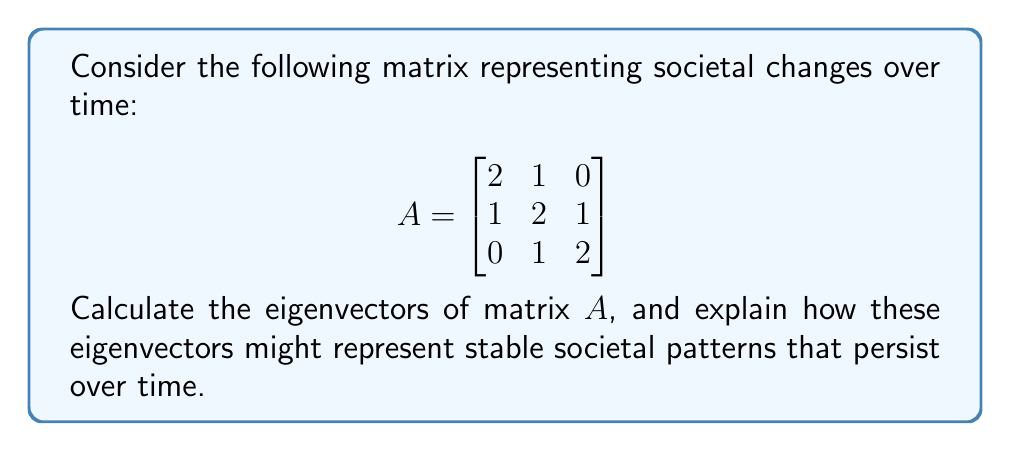Give your solution to this math problem. To find the eigenvectors of matrix $A$, we follow these steps:

1) First, we calculate the characteristic polynomial:
   $det(A - \lambda I) = \begin{vmatrix}
   2-\lambda & 1 & 0 \\
   1 & 2-\lambda & 1 \\
   0 & 1 & 2-\lambda
   \end{vmatrix} = 0$

2) Expanding this determinant:
   $(2-\lambda)^3 + 2 - 3(2-\lambda) = 0$
   $(2-\lambda)^3 - 3(2-\lambda) + 2 = 0$
   $\lambda^3 - 6\lambda^2 + 11\lambda - 6 = 0$

3) Factoring this polynomial:
   $(\lambda - 1)(\lambda - 2)(\lambda - 3) = 0$

4) So, the eigenvalues are $\lambda_1 = 1$, $\lambda_2 = 2$, and $\lambda_3 = 3$.

5) For each eigenvalue, we solve $(A - \lambda I)v = 0$ to find the corresponding eigenvector:

   For $\lambda_1 = 1$:
   $\begin{bmatrix}
   1 & 1 & 0 \\
   1 & 1 & 1 \\
   0 & 1 & 1
   \end{bmatrix} \begin{bmatrix} x \\ y \\ z \end{bmatrix} = \begin{bmatrix} 0 \\ 0 \\ 0 \end{bmatrix}$

   Solving this system, we get $v_1 = \begin{bmatrix} 1 \\ -1 \\ 1 \end{bmatrix}$

   For $\lambda_2 = 2$:
   $\begin{bmatrix}
   0 & 1 & 0 \\
   1 & 0 & 1 \\
   0 & 1 & 0
   \end{bmatrix} \begin{bmatrix} x \\ y \\ z \end{bmatrix} = \begin{bmatrix} 0 \\ 0 \\ 0 \end{bmatrix}$

   Solving this system, we get $v_2 = \begin{bmatrix} 1 \\ 0 \\ -1 \end{bmatrix}$

   For $\lambda_3 = 3$:
   $\begin{bmatrix}
   -1 & 1 & 0 \\
   1 & -1 & 1 \\
   0 & 1 & -1
   \end{bmatrix} \begin{bmatrix} x \\ y \\ z \end{bmatrix} = \begin{bmatrix} 0 \\ 0 \\ 0 \end{bmatrix}$

   Solving this system, we get $v_3 = \begin{bmatrix} 1 \\ 1 \\ 1 \end{bmatrix}$

These eigenvectors represent stable societal patterns that persist over time. The first eigenvector $v_1$ might represent a cyclical pattern, the second $v_2$ a polarizing trend, and the third $v_3$ a uniform growth or decline across all sectors.
Answer: $v_1 = \begin{bmatrix} 1 \\ -1 \\ 1 \end{bmatrix}$, $v_2 = \begin{bmatrix} 1 \\ 0 \\ -1 \end{bmatrix}$, $v_3 = \begin{bmatrix} 1 \\ 1 \\ 1 \end{bmatrix}$ 